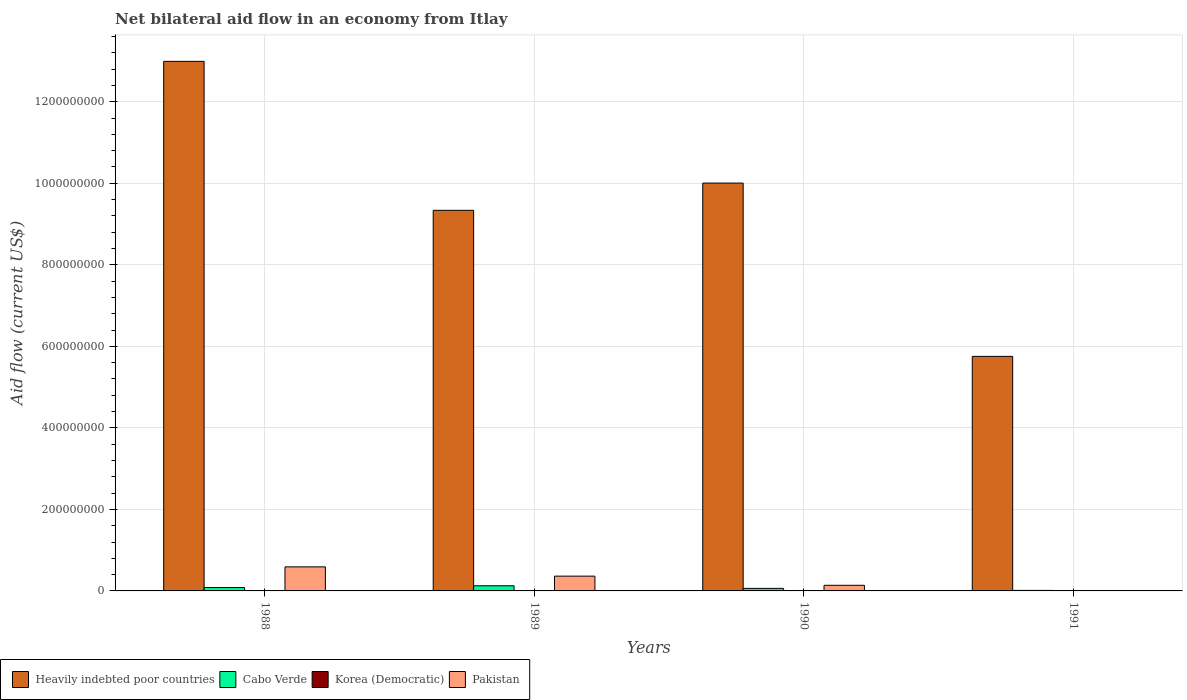How many different coloured bars are there?
Your answer should be very brief. 4. How many groups of bars are there?
Provide a succinct answer. 4. How many bars are there on the 3rd tick from the left?
Your answer should be compact. 4. How many bars are there on the 2nd tick from the right?
Offer a very short reply. 4. What is the label of the 3rd group of bars from the left?
Provide a succinct answer. 1990. What is the net bilateral aid flow in Heavily indebted poor countries in 1989?
Your answer should be very brief. 9.34e+08. Across all years, what is the maximum net bilateral aid flow in Cabo Verde?
Provide a short and direct response. 1.26e+07. Across all years, what is the minimum net bilateral aid flow in Cabo Verde?
Ensure brevity in your answer.  1.25e+06. In which year was the net bilateral aid flow in Cabo Verde maximum?
Keep it short and to the point. 1989. What is the total net bilateral aid flow in Cabo Verde in the graph?
Make the answer very short. 2.84e+07. What is the difference between the net bilateral aid flow in Pakistan in 1988 and that in 1989?
Keep it short and to the point. 2.27e+07. What is the difference between the net bilateral aid flow in Cabo Verde in 1988 and the net bilateral aid flow in Heavily indebted poor countries in 1989?
Offer a very short reply. -9.25e+08. What is the average net bilateral aid flow in Heavily indebted poor countries per year?
Your answer should be compact. 9.52e+08. In the year 1989, what is the difference between the net bilateral aid flow in Heavily indebted poor countries and net bilateral aid flow in Korea (Democratic)?
Make the answer very short. 9.34e+08. What is the ratio of the net bilateral aid flow in Pakistan in 1988 to that in 1989?
Offer a very short reply. 1.63. Is the net bilateral aid flow in Pakistan in 1988 less than that in 1989?
Provide a short and direct response. No. Is the difference between the net bilateral aid flow in Heavily indebted poor countries in 1988 and 1989 greater than the difference between the net bilateral aid flow in Korea (Democratic) in 1988 and 1989?
Provide a succinct answer. Yes. What is the difference between the highest and the second highest net bilateral aid flow in Heavily indebted poor countries?
Offer a very short reply. 2.99e+08. What is the difference between the highest and the lowest net bilateral aid flow in Pakistan?
Your response must be concise. 5.90e+07. In how many years, is the net bilateral aid flow in Korea (Democratic) greater than the average net bilateral aid flow in Korea (Democratic) taken over all years?
Your answer should be very brief. 2. Is the sum of the net bilateral aid flow in Pakistan in 1988 and 1989 greater than the maximum net bilateral aid flow in Korea (Democratic) across all years?
Give a very brief answer. Yes. Are all the bars in the graph horizontal?
Ensure brevity in your answer.  No. How many years are there in the graph?
Give a very brief answer. 4. Are the values on the major ticks of Y-axis written in scientific E-notation?
Make the answer very short. No. Does the graph contain any zero values?
Provide a succinct answer. Yes. How are the legend labels stacked?
Offer a terse response. Horizontal. What is the title of the graph?
Ensure brevity in your answer.  Net bilateral aid flow in an economy from Itlay. What is the Aid flow (current US$) of Heavily indebted poor countries in 1988?
Make the answer very short. 1.30e+09. What is the Aid flow (current US$) of Cabo Verde in 1988?
Keep it short and to the point. 8.28e+06. What is the Aid flow (current US$) of Korea (Democratic) in 1988?
Offer a very short reply. 1.70e+05. What is the Aid flow (current US$) of Pakistan in 1988?
Provide a short and direct response. 5.90e+07. What is the Aid flow (current US$) of Heavily indebted poor countries in 1989?
Ensure brevity in your answer.  9.34e+08. What is the Aid flow (current US$) of Cabo Verde in 1989?
Keep it short and to the point. 1.26e+07. What is the Aid flow (current US$) in Pakistan in 1989?
Offer a terse response. 3.63e+07. What is the Aid flow (current US$) in Heavily indebted poor countries in 1990?
Ensure brevity in your answer.  1.00e+09. What is the Aid flow (current US$) in Cabo Verde in 1990?
Your response must be concise. 6.27e+06. What is the Aid flow (current US$) of Pakistan in 1990?
Provide a succinct answer. 1.38e+07. What is the Aid flow (current US$) in Heavily indebted poor countries in 1991?
Provide a short and direct response. 5.75e+08. What is the Aid flow (current US$) of Cabo Verde in 1991?
Your response must be concise. 1.25e+06. What is the Aid flow (current US$) of Pakistan in 1991?
Provide a short and direct response. 0. Across all years, what is the maximum Aid flow (current US$) in Heavily indebted poor countries?
Offer a terse response. 1.30e+09. Across all years, what is the maximum Aid flow (current US$) of Cabo Verde?
Offer a terse response. 1.26e+07. Across all years, what is the maximum Aid flow (current US$) of Korea (Democratic)?
Offer a very short reply. 1.70e+05. Across all years, what is the maximum Aid flow (current US$) in Pakistan?
Your answer should be very brief. 5.90e+07. Across all years, what is the minimum Aid flow (current US$) of Heavily indebted poor countries?
Keep it short and to the point. 5.75e+08. Across all years, what is the minimum Aid flow (current US$) of Cabo Verde?
Ensure brevity in your answer.  1.25e+06. What is the total Aid flow (current US$) in Heavily indebted poor countries in the graph?
Your answer should be compact. 3.81e+09. What is the total Aid flow (current US$) in Cabo Verde in the graph?
Keep it short and to the point. 2.84e+07. What is the total Aid flow (current US$) of Korea (Democratic) in the graph?
Ensure brevity in your answer.  4.80e+05. What is the total Aid flow (current US$) in Pakistan in the graph?
Offer a very short reply. 1.09e+08. What is the difference between the Aid flow (current US$) in Heavily indebted poor countries in 1988 and that in 1989?
Provide a succinct answer. 3.65e+08. What is the difference between the Aid flow (current US$) of Cabo Verde in 1988 and that in 1989?
Give a very brief answer. -4.33e+06. What is the difference between the Aid flow (current US$) in Korea (Democratic) in 1988 and that in 1989?
Give a very brief answer. 5.00e+04. What is the difference between the Aid flow (current US$) in Pakistan in 1988 and that in 1989?
Provide a succinct answer. 2.27e+07. What is the difference between the Aid flow (current US$) of Heavily indebted poor countries in 1988 and that in 1990?
Offer a terse response. 2.99e+08. What is the difference between the Aid flow (current US$) in Cabo Verde in 1988 and that in 1990?
Your answer should be compact. 2.01e+06. What is the difference between the Aid flow (current US$) in Pakistan in 1988 and that in 1990?
Ensure brevity in your answer.  4.52e+07. What is the difference between the Aid flow (current US$) of Heavily indebted poor countries in 1988 and that in 1991?
Make the answer very short. 7.24e+08. What is the difference between the Aid flow (current US$) of Cabo Verde in 1988 and that in 1991?
Your answer should be very brief. 7.03e+06. What is the difference between the Aid flow (current US$) in Heavily indebted poor countries in 1989 and that in 1990?
Your answer should be compact. -6.68e+07. What is the difference between the Aid flow (current US$) in Cabo Verde in 1989 and that in 1990?
Ensure brevity in your answer.  6.34e+06. What is the difference between the Aid flow (current US$) in Korea (Democratic) in 1989 and that in 1990?
Provide a succinct answer. -2.00e+04. What is the difference between the Aid flow (current US$) of Pakistan in 1989 and that in 1990?
Provide a short and direct response. 2.25e+07. What is the difference between the Aid flow (current US$) in Heavily indebted poor countries in 1989 and that in 1991?
Give a very brief answer. 3.58e+08. What is the difference between the Aid flow (current US$) in Cabo Verde in 1989 and that in 1991?
Give a very brief answer. 1.14e+07. What is the difference between the Aid flow (current US$) of Korea (Democratic) in 1989 and that in 1991?
Your response must be concise. 7.00e+04. What is the difference between the Aid flow (current US$) of Heavily indebted poor countries in 1990 and that in 1991?
Make the answer very short. 4.25e+08. What is the difference between the Aid flow (current US$) in Cabo Verde in 1990 and that in 1991?
Keep it short and to the point. 5.02e+06. What is the difference between the Aid flow (current US$) in Korea (Democratic) in 1990 and that in 1991?
Provide a short and direct response. 9.00e+04. What is the difference between the Aid flow (current US$) in Heavily indebted poor countries in 1988 and the Aid flow (current US$) in Cabo Verde in 1989?
Your answer should be compact. 1.29e+09. What is the difference between the Aid flow (current US$) in Heavily indebted poor countries in 1988 and the Aid flow (current US$) in Korea (Democratic) in 1989?
Offer a terse response. 1.30e+09. What is the difference between the Aid flow (current US$) in Heavily indebted poor countries in 1988 and the Aid flow (current US$) in Pakistan in 1989?
Make the answer very short. 1.26e+09. What is the difference between the Aid flow (current US$) in Cabo Verde in 1988 and the Aid flow (current US$) in Korea (Democratic) in 1989?
Ensure brevity in your answer.  8.16e+06. What is the difference between the Aid flow (current US$) in Cabo Verde in 1988 and the Aid flow (current US$) in Pakistan in 1989?
Offer a very short reply. -2.80e+07. What is the difference between the Aid flow (current US$) of Korea (Democratic) in 1988 and the Aid flow (current US$) of Pakistan in 1989?
Provide a short and direct response. -3.61e+07. What is the difference between the Aid flow (current US$) in Heavily indebted poor countries in 1988 and the Aid flow (current US$) in Cabo Verde in 1990?
Give a very brief answer. 1.29e+09. What is the difference between the Aid flow (current US$) in Heavily indebted poor countries in 1988 and the Aid flow (current US$) in Korea (Democratic) in 1990?
Offer a terse response. 1.30e+09. What is the difference between the Aid flow (current US$) in Heavily indebted poor countries in 1988 and the Aid flow (current US$) in Pakistan in 1990?
Provide a short and direct response. 1.29e+09. What is the difference between the Aid flow (current US$) of Cabo Verde in 1988 and the Aid flow (current US$) of Korea (Democratic) in 1990?
Keep it short and to the point. 8.14e+06. What is the difference between the Aid flow (current US$) in Cabo Verde in 1988 and the Aid flow (current US$) in Pakistan in 1990?
Offer a terse response. -5.51e+06. What is the difference between the Aid flow (current US$) in Korea (Democratic) in 1988 and the Aid flow (current US$) in Pakistan in 1990?
Your answer should be very brief. -1.36e+07. What is the difference between the Aid flow (current US$) in Heavily indebted poor countries in 1988 and the Aid flow (current US$) in Cabo Verde in 1991?
Keep it short and to the point. 1.30e+09. What is the difference between the Aid flow (current US$) in Heavily indebted poor countries in 1988 and the Aid flow (current US$) in Korea (Democratic) in 1991?
Offer a terse response. 1.30e+09. What is the difference between the Aid flow (current US$) in Cabo Verde in 1988 and the Aid flow (current US$) in Korea (Democratic) in 1991?
Give a very brief answer. 8.23e+06. What is the difference between the Aid flow (current US$) in Heavily indebted poor countries in 1989 and the Aid flow (current US$) in Cabo Verde in 1990?
Keep it short and to the point. 9.27e+08. What is the difference between the Aid flow (current US$) in Heavily indebted poor countries in 1989 and the Aid flow (current US$) in Korea (Democratic) in 1990?
Your answer should be compact. 9.34e+08. What is the difference between the Aid flow (current US$) in Heavily indebted poor countries in 1989 and the Aid flow (current US$) in Pakistan in 1990?
Your response must be concise. 9.20e+08. What is the difference between the Aid flow (current US$) of Cabo Verde in 1989 and the Aid flow (current US$) of Korea (Democratic) in 1990?
Your response must be concise. 1.25e+07. What is the difference between the Aid flow (current US$) in Cabo Verde in 1989 and the Aid flow (current US$) in Pakistan in 1990?
Provide a succinct answer. -1.18e+06. What is the difference between the Aid flow (current US$) in Korea (Democratic) in 1989 and the Aid flow (current US$) in Pakistan in 1990?
Provide a short and direct response. -1.37e+07. What is the difference between the Aid flow (current US$) in Heavily indebted poor countries in 1989 and the Aid flow (current US$) in Cabo Verde in 1991?
Make the answer very short. 9.32e+08. What is the difference between the Aid flow (current US$) of Heavily indebted poor countries in 1989 and the Aid flow (current US$) of Korea (Democratic) in 1991?
Your response must be concise. 9.34e+08. What is the difference between the Aid flow (current US$) in Cabo Verde in 1989 and the Aid flow (current US$) in Korea (Democratic) in 1991?
Provide a short and direct response. 1.26e+07. What is the difference between the Aid flow (current US$) of Heavily indebted poor countries in 1990 and the Aid flow (current US$) of Cabo Verde in 1991?
Your answer should be compact. 9.99e+08. What is the difference between the Aid flow (current US$) in Heavily indebted poor countries in 1990 and the Aid flow (current US$) in Korea (Democratic) in 1991?
Give a very brief answer. 1.00e+09. What is the difference between the Aid flow (current US$) of Cabo Verde in 1990 and the Aid flow (current US$) of Korea (Democratic) in 1991?
Provide a short and direct response. 6.22e+06. What is the average Aid flow (current US$) in Heavily indebted poor countries per year?
Provide a succinct answer. 9.52e+08. What is the average Aid flow (current US$) of Cabo Verde per year?
Keep it short and to the point. 7.10e+06. What is the average Aid flow (current US$) of Korea (Democratic) per year?
Your response must be concise. 1.20e+05. What is the average Aid flow (current US$) in Pakistan per year?
Offer a very short reply. 2.73e+07. In the year 1988, what is the difference between the Aid flow (current US$) in Heavily indebted poor countries and Aid flow (current US$) in Cabo Verde?
Your response must be concise. 1.29e+09. In the year 1988, what is the difference between the Aid flow (current US$) in Heavily indebted poor countries and Aid flow (current US$) in Korea (Democratic)?
Give a very brief answer. 1.30e+09. In the year 1988, what is the difference between the Aid flow (current US$) in Heavily indebted poor countries and Aid flow (current US$) in Pakistan?
Provide a succinct answer. 1.24e+09. In the year 1988, what is the difference between the Aid flow (current US$) in Cabo Verde and Aid flow (current US$) in Korea (Democratic)?
Provide a short and direct response. 8.11e+06. In the year 1988, what is the difference between the Aid flow (current US$) in Cabo Verde and Aid flow (current US$) in Pakistan?
Ensure brevity in your answer.  -5.07e+07. In the year 1988, what is the difference between the Aid flow (current US$) of Korea (Democratic) and Aid flow (current US$) of Pakistan?
Your answer should be very brief. -5.88e+07. In the year 1989, what is the difference between the Aid flow (current US$) of Heavily indebted poor countries and Aid flow (current US$) of Cabo Verde?
Your answer should be very brief. 9.21e+08. In the year 1989, what is the difference between the Aid flow (current US$) of Heavily indebted poor countries and Aid flow (current US$) of Korea (Democratic)?
Your answer should be very brief. 9.34e+08. In the year 1989, what is the difference between the Aid flow (current US$) in Heavily indebted poor countries and Aid flow (current US$) in Pakistan?
Your response must be concise. 8.97e+08. In the year 1989, what is the difference between the Aid flow (current US$) in Cabo Verde and Aid flow (current US$) in Korea (Democratic)?
Offer a terse response. 1.25e+07. In the year 1989, what is the difference between the Aid flow (current US$) in Cabo Verde and Aid flow (current US$) in Pakistan?
Ensure brevity in your answer.  -2.36e+07. In the year 1989, what is the difference between the Aid flow (current US$) of Korea (Democratic) and Aid flow (current US$) of Pakistan?
Offer a terse response. -3.61e+07. In the year 1990, what is the difference between the Aid flow (current US$) in Heavily indebted poor countries and Aid flow (current US$) in Cabo Verde?
Offer a terse response. 9.94e+08. In the year 1990, what is the difference between the Aid flow (current US$) of Heavily indebted poor countries and Aid flow (current US$) of Korea (Democratic)?
Offer a terse response. 1.00e+09. In the year 1990, what is the difference between the Aid flow (current US$) of Heavily indebted poor countries and Aid flow (current US$) of Pakistan?
Provide a short and direct response. 9.87e+08. In the year 1990, what is the difference between the Aid flow (current US$) in Cabo Verde and Aid flow (current US$) in Korea (Democratic)?
Make the answer very short. 6.13e+06. In the year 1990, what is the difference between the Aid flow (current US$) in Cabo Verde and Aid flow (current US$) in Pakistan?
Provide a short and direct response. -7.52e+06. In the year 1990, what is the difference between the Aid flow (current US$) in Korea (Democratic) and Aid flow (current US$) in Pakistan?
Keep it short and to the point. -1.36e+07. In the year 1991, what is the difference between the Aid flow (current US$) of Heavily indebted poor countries and Aid flow (current US$) of Cabo Verde?
Offer a terse response. 5.74e+08. In the year 1991, what is the difference between the Aid flow (current US$) of Heavily indebted poor countries and Aid flow (current US$) of Korea (Democratic)?
Your answer should be very brief. 5.75e+08. In the year 1991, what is the difference between the Aid flow (current US$) of Cabo Verde and Aid flow (current US$) of Korea (Democratic)?
Give a very brief answer. 1.20e+06. What is the ratio of the Aid flow (current US$) in Heavily indebted poor countries in 1988 to that in 1989?
Your answer should be compact. 1.39. What is the ratio of the Aid flow (current US$) in Cabo Verde in 1988 to that in 1989?
Make the answer very short. 0.66. What is the ratio of the Aid flow (current US$) of Korea (Democratic) in 1988 to that in 1989?
Give a very brief answer. 1.42. What is the ratio of the Aid flow (current US$) of Pakistan in 1988 to that in 1989?
Make the answer very short. 1.63. What is the ratio of the Aid flow (current US$) of Heavily indebted poor countries in 1988 to that in 1990?
Give a very brief answer. 1.3. What is the ratio of the Aid flow (current US$) of Cabo Verde in 1988 to that in 1990?
Make the answer very short. 1.32. What is the ratio of the Aid flow (current US$) of Korea (Democratic) in 1988 to that in 1990?
Keep it short and to the point. 1.21. What is the ratio of the Aid flow (current US$) of Pakistan in 1988 to that in 1990?
Provide a succinct answer. 4.28. What is the ratio of the Aid flow (current US$) of Heavily indebted poor countries in 1988 to that in 1991?
Your answer should be very brief. 2.26. What is the ratio of the Aid flow (current US$) in Cabo Verde in 1988 to that in 1991?
Provide a succinct answer. 6.62. What is the ratio of the Aid flow (current US$) of Korea (Democratic) in 1988 to that in 1991?
Offer a terse response. 3.4. What is the ratio of the Aid flow (current US$) in Heavily indebted poor countries in 1989 to that in 1990?
Your response must be concise. 0.93. What is the ratio of the Aid flow (current US$) of Cabo Verde in 1989 to that in 1990?
Provide a succinct answer. 2.01. What is the ratio of the Aid flow (current US$) in Pakistan in 1989 to that in 1990?
Your response must be concise. 2.63. What is the ratio of the Aid flow (current US$) in Heavily indebted poor countries in 1989 to that in 1991?
Provide a succinct answer. 1.62. What is the ratio of the Aid flow (current US$) in Cabo Verde in 1989 to that in 1991?
Offer a very short reply. 10.09. What is the ratio of the Aid flow (current US$) of Korea (Democratic) in 1989 to that in 1991?
Your answer should be very brief. 2.4. What is the ratio of the Aid flow (current US$) of Heavily indebted poor countries in 1990 to that in 1991?
Ensure brevity in your answer.  1.74. What is the ratio of the Aid flow (current US$) in Cabo Verde in 1990 to that in 1991?
Your answer should be very brief. 5.02. What is the ratio of the Aid flow (current US$) in Korea (Democratic) in 1990 to that in 1991?
Keep it short and to the point. 2.8. What is the difference between the highest and the second highest Aid flow (current US$) in Heavily indebted poor countries?
Provide a short and direct response. 2.99e+08. What is the difference between the highest and the second highest Aid flow (current US$) of Cabo Verde?
Offer a terse response. 4.33e+06. What is the difference between the highest and the second highest Aid flow (current US$) in Pakistan?
Ensure brevity in your answer.  2.27e+07. What is the difference between the highest and the lowest Aid flow (current US$) in Heavily indebted poor countries?
Ensure brevity in your answer.  7.24e+08. What is the difference between the highest and the lowest Aid flow (current US$) of Cabo Verde?
Provide a short and direct response. 1.14e+07. What is the difference between the highest and the lowest Aid flow (current US$) in Korea (Democratic)?
Keep it short and to the point. 1.20e+05. What is the difference between the highest and the lowest Aid flow (current US$) of Pakistan?
Give a very brief answer. 5.90e+07. 